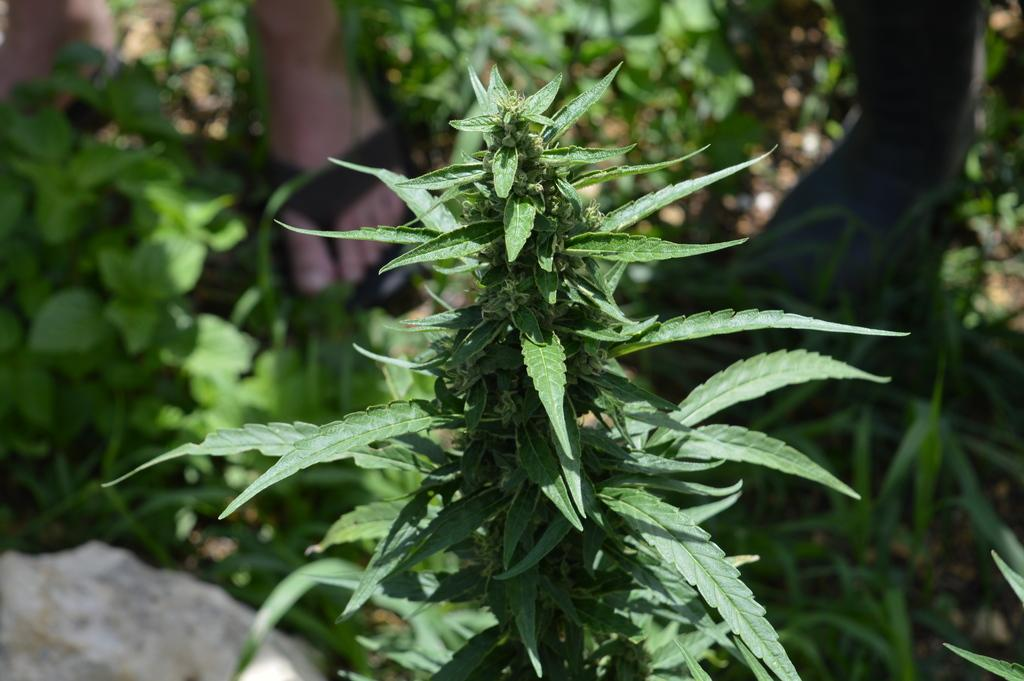What type of vegetation can be seen in the image? There are green leaves in the image. How would you describe the background of the image? The background of the image is blurred. What other object can be seen in the image besides the leaves? There is a rock in the image. What else is present in the image related to plants? Leaves are present in the image. Can you describe any part of a person visible in the image? Person's legs are visible in the image. How many bikes are parked next to the person's legs in the image? There are no bikes present in the image; only green leaves, a rock, and a person's legs can be seen. What type of yam is being held by the person in the image? There is no person holding a yam in the image; only their legs are visible. 